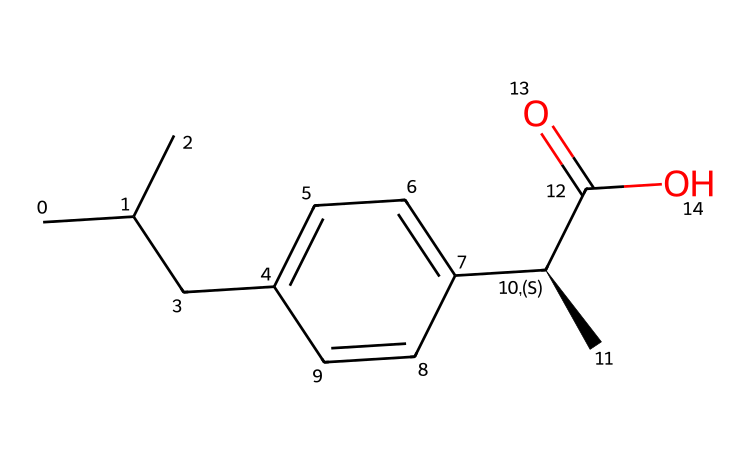What is the molecular formula of ibuprofen? To find the molecular formula, we count the number of each type of atom in the SMILES representation. From the structure, we have 13 carbon (C), 18 hydrogen (H), and 2 oxygen (O) atoms. Therefore, the molecular formula is C13H18O2.
Answer: C13H18O2 How many chiral centers are present in ibuprofen? In the provided SMILES, we note that the symbol `[C@H]` indicates the presence of a chiral center at that carbon atom. Analyzing the structure, we find there is only one chiral center in ibuprofen.
Answer: 1 What functional group is primarily responsible for ibuprofen's acidity? The presence of the carboxylic acid group (-COOH) is visible in the structure of ibuprofen, specifically at the end of the molecule. This group is known for its acidic properties.
Answer: carboxylic acid Which part of the molecule contributes to its anti-inflammatory properties? The presence of the aromatic ring, which is characteristic of non-steroidal anti-inflammatory drugs (NSAIDs) like ibuprofen, plays a crucial role in its anti-inflammatory effects.
Answer: aromatic ring What is the primary type of intermolecular force that ibuprofen molecules use for solubility in water? Given the presence of a polar functional group (the carboxylic acid), ibuprofen engages in hydrogen bonding with water molecules, which enhances its solubility.
Answer: hydrogen bonding 